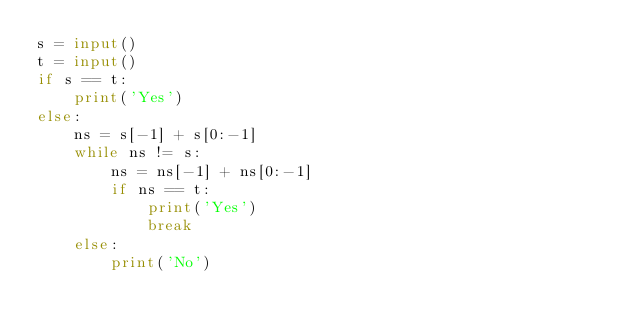<code> <loc_0><loc_0><loc_500><loc_500><_Python_>s = input()
t = input()
if s == t:
    print('Yes')
else:
    ns = s[-1] + s[0:-1]
    while ns != s:
        ns = ns[-1] + ns[0:-1]
        if ns == t:
            print('Yes')
            break
    else:
        print('No')</code> 